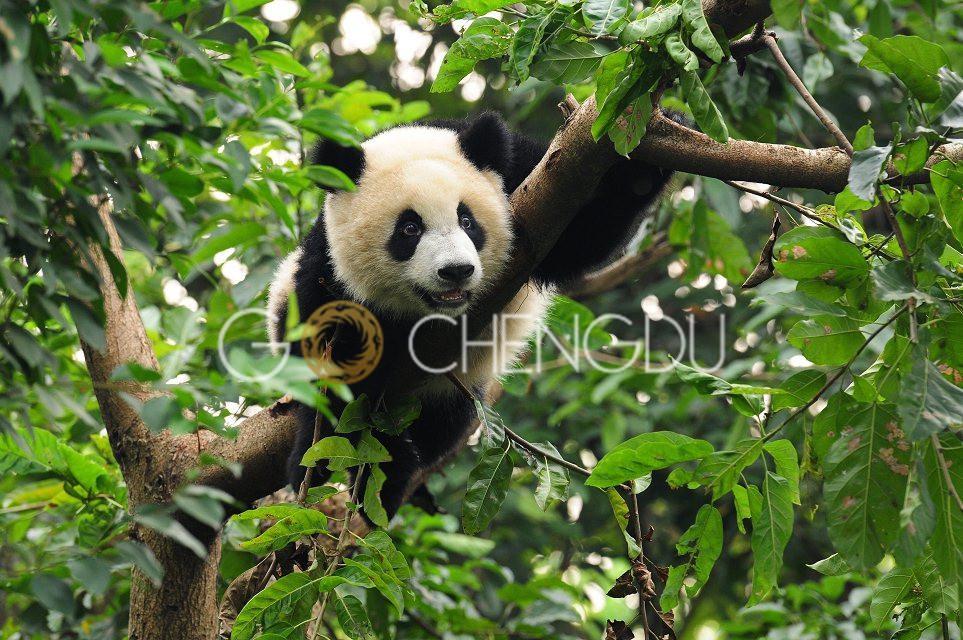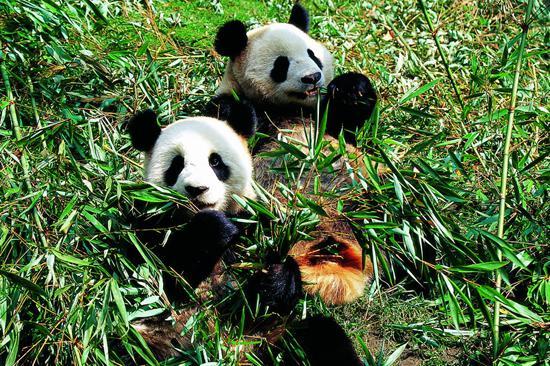The first image is the image on the left, the second image is the image on the right. For the images displayed, is the sentence "The left image contains exactly one panda." factually correct? Answer yes or no. Yes. The first image is the image on the left, the second image is the image on the right. Considering the images on both sides, is "A panda is climbing a wooden limb in one image, and pandas are munching on bamboo leaves in the other image." valid? Answer yes or no. Yes. 